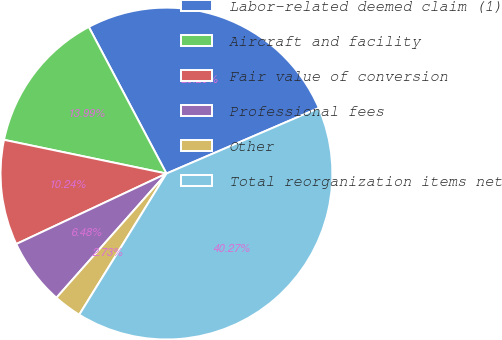Convert chart to OTSL. <chart><loc_0><loc_0><loc_500><loc_500><pie_chart><fcel>Labor-related deemed claim (1)<fcel>Aircraft and facility<fcel>Fair value of conversion<fcel>Professional fees<fcel>Other<fcel>Total reorganization items net<nl><fcel>26.29%<fcel>13.99%<fcel>10.24%<fcel>6.48%<fcel>2.73%<fcel>40.27%<nl></chart> 